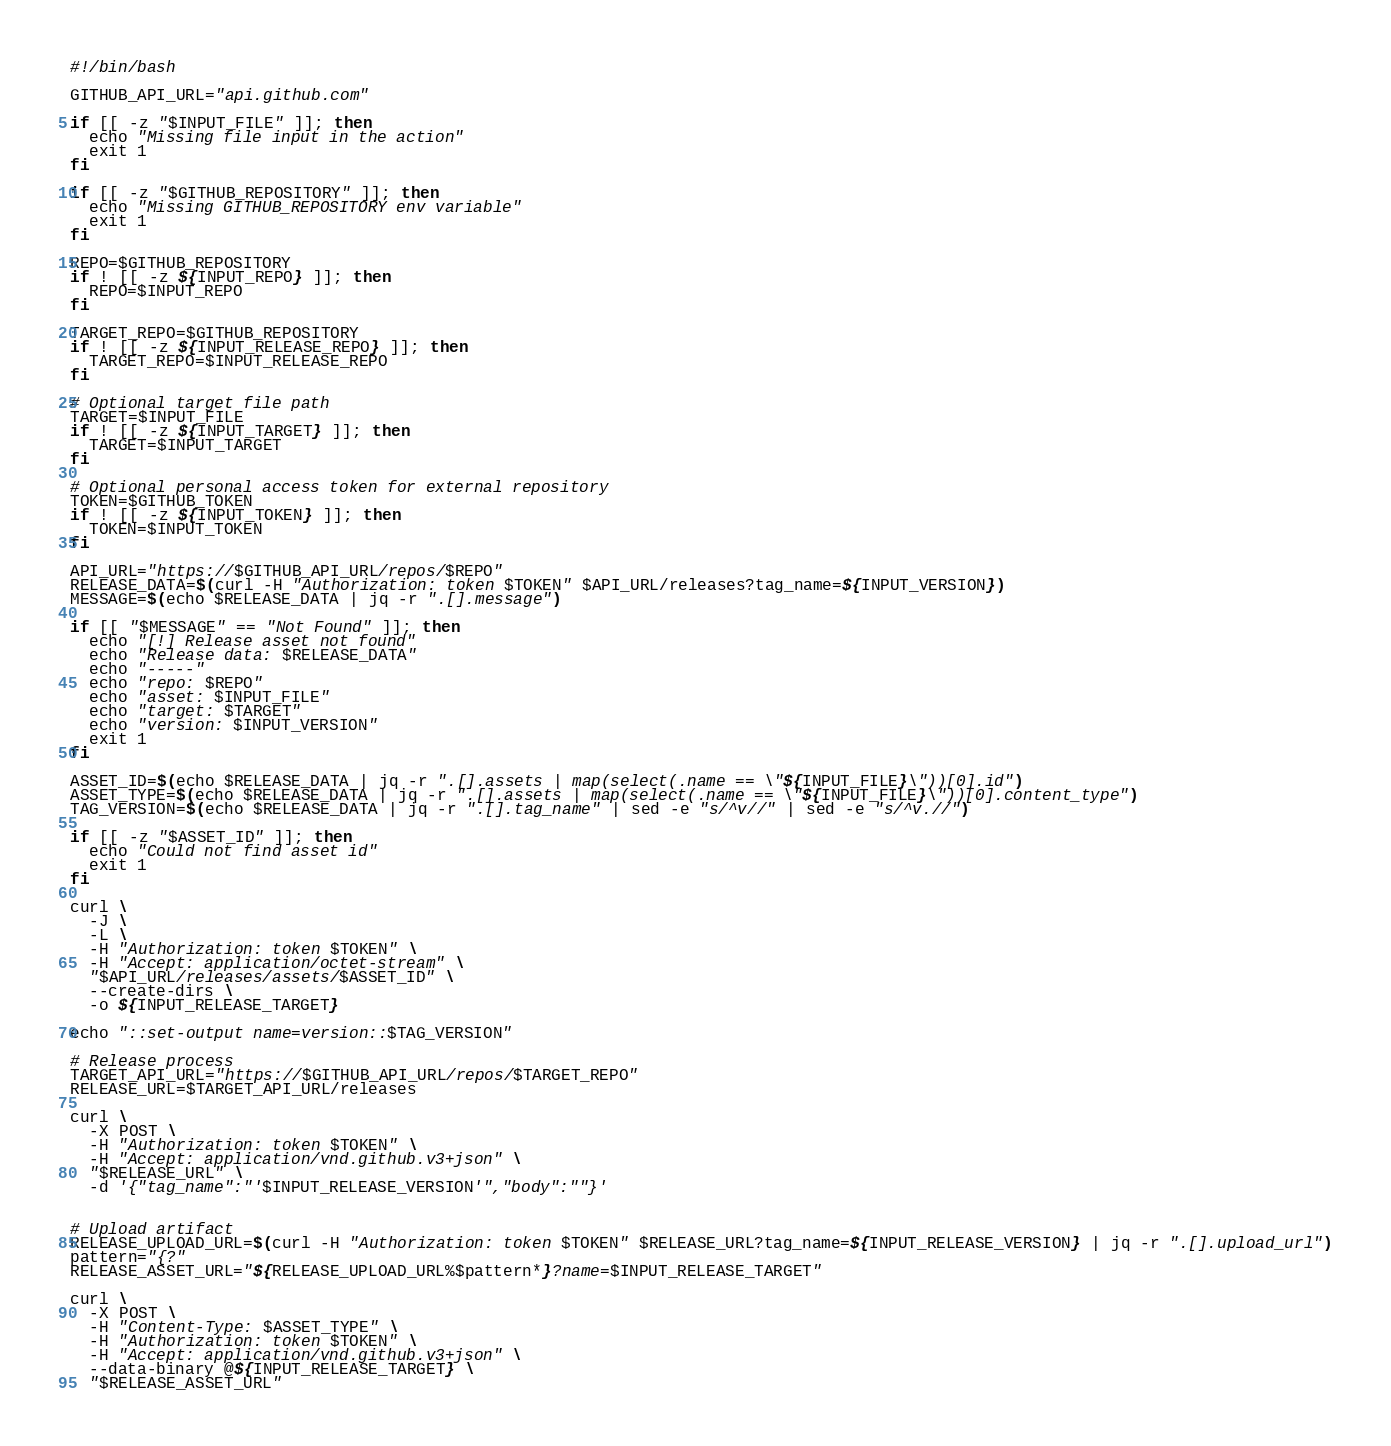<code> <loc_0><loc_0><loc_500><loc_500><_Bash_>#!/bin/bash

GITHUB_API_URL="api.github.com"

if [[ -z "$INPUT_FILE" ]]; then
  echo "Missing file input in the action"
  exit 1
fi

if [[ -z "$GITHUB_REPOSITORY" ]]; then
  echo "Missing GITHUB_REPOSITORY env variable"
  exit 1
fi

REPO=$GITHUB_REPOSITORY
if ! [[ -z ${INPUT_REPO} ]]; then
  REPO=$INPUT_REPO
fi

TARGET_REPO=$GITHUB_REPOSITORY
if ! [[ -z ${INPUT_RELEASE_REPO} ]]; then
  TARGET_REPO=$INPUT_RELEASE_REPO
fi

# Optional target file path
TARGET=$INPUT_FILE
if ! [[ -z ${INPUT_TARGET} ]]; then
  TARGET=$INPUT_TARGET
fi

# Optional personal access token for external repository
TOKEN=$GITHUB_TOKEN
if ! [[ -z ${INPUT_TOKEN} ]]; then
  TOKEN=$INPUT_TOKEN
fi

API_URL="https://$GITHUB_API_URL/repos/$REPO"
RELEASE_DATA=$(curl -H "Authorization: token $TOKEN" $API_URL/releases?tag_name=${INPUT_VERSION})
MESSAGE=$(echo $RELEASE_DATA | jq -r ".[].message")

if [[ "$MESSAGE" == "Not Found" ]]; then
  echo "[!] Release asset not found"
  echo "Release data: $RELEASE_DATA"
  echo "-----"
  echo "repo: $REPO"
  echo "asset: $INPUT_FILE"
  echo "target: $TARGET"
  echo "version: $INPUT_VERSION"
  exit 1
fi

ASSET_ID=$(echo $RELEASE_DATA | jq -r ".[].assets | map(select(.name == \"${INPUT_FILE}\"))[0].id")
ASSET_TYPE=$(echo $RELEASE_DATA | jq -r ".[].assets | map(select(.name == \"${INPUT_FILE}\"))[0].content_type")
TAG_VERSION=$(echo $RELEASE_DATA | jq -r ".[].tag_name" | sed -e "s/^v//" | sed -e "s/^v.//")

if [[ -z "$ASSET_ID" ]]; then
  echo "Could not find asset id"
  exit 1
fi

curl \
  -J \
  -L \
  -H "Authorization: token $TOKEN" \
  -H "Accept: application/octet-stream" \
  "$API_URL/releases/assets/$ASSET_ID" \
  --create-dirs \
  -o ${INPUT_RELEASE_TARGET}

echo "::set-output name=version::$TAG_VERSION"

# Release process
TARGET_API_URL="https://$GITHUB_API_URL/repos/$TARGET_REPO"
RELEASE_URL=$TARGET_API_URL/releases

curl \
  -X POST \
  -H "Authorization: token $TOKEN" \
  -H "Accept: application/vnd.github.v3+json" \
  "$RELEASE_URL" \
  -d '{"tag_name":"'$INPUT_RELEASE_VERSION'","body":""}'


# Upload artifact
RELEASE_UPLOAD_URL=$(curl -H "Authorization: token $TOKEN" $RELEASE_URL?tag_name=${INPUT_RELEASE_VERSION} | jq -r ".[].upload_url")
pattern="{?"
RELEASE_ASSET_URL="${RELEASE_UPLOAD_URL%$pattern*}?name=$INPUT_RELEASE_TARGET"

curl \
  -X POST \
  -H "Content-Type: $ASSET_TYPE" \
  -H "Authorization: token $TOKEN" \
  -H "Accept: application/vnd.github.v3+json" \
  --data-binary @${INPUT_RELEASE_TARGET} \
  "$RELEASE_ASSET_URL"</code> 